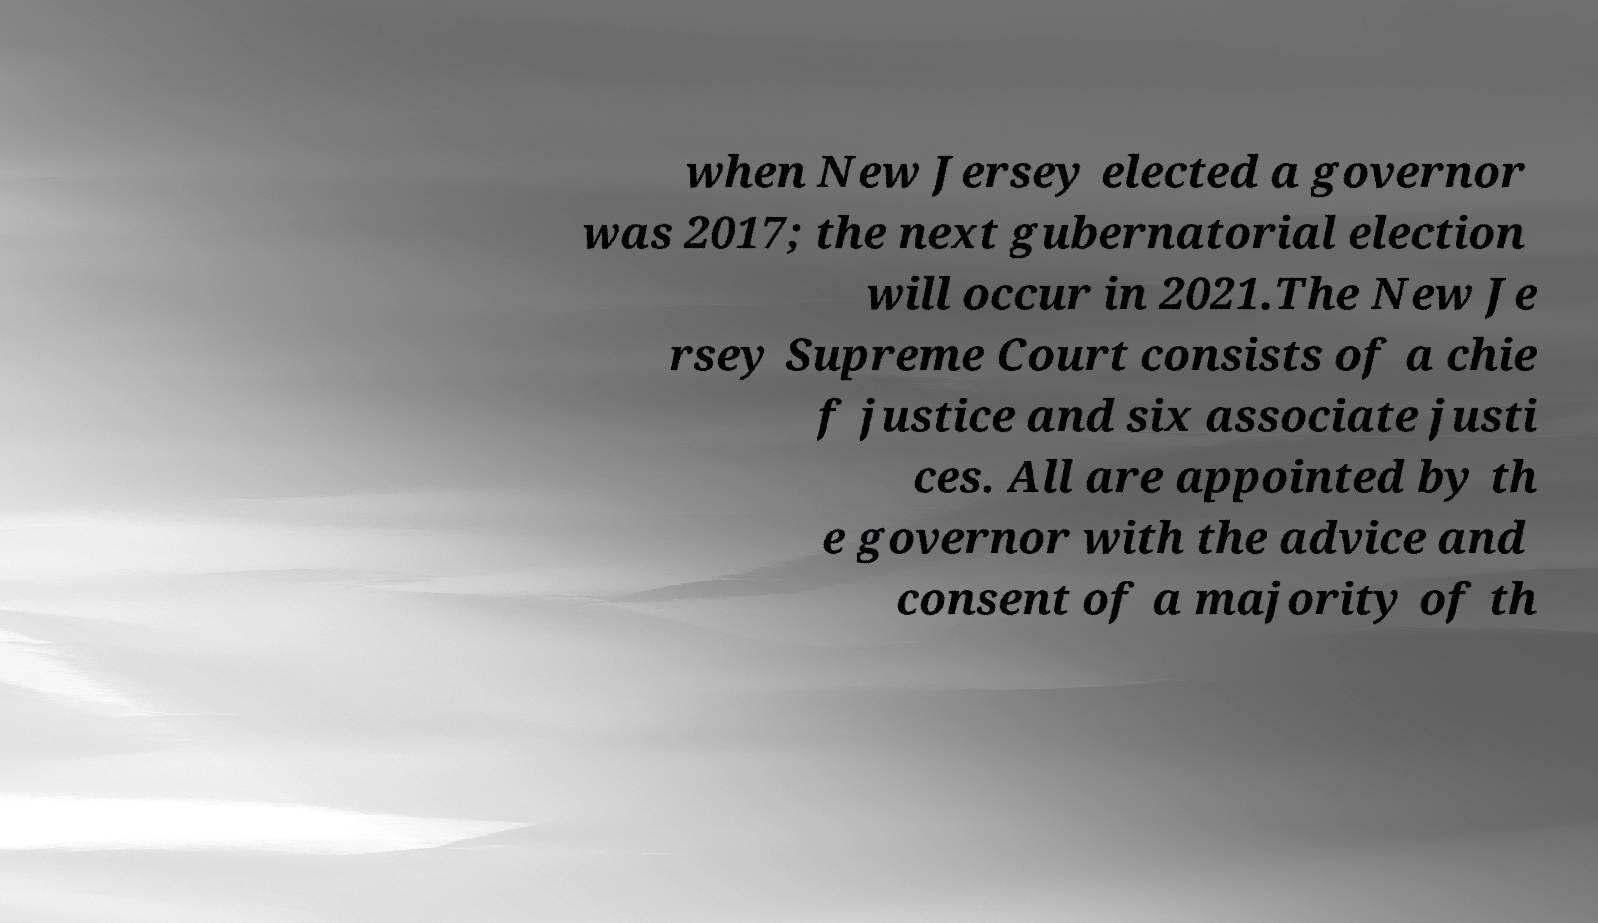Please identify and transcribe the text found in this image. when New Jersey elected a governor was 2017; the next gubernatorial election will occur in 2021.The New Je rsey Supreme Court consists of a chie f justice and six associate justi ces. All are appointed by th e governor with the advice and consent of a majority of th 